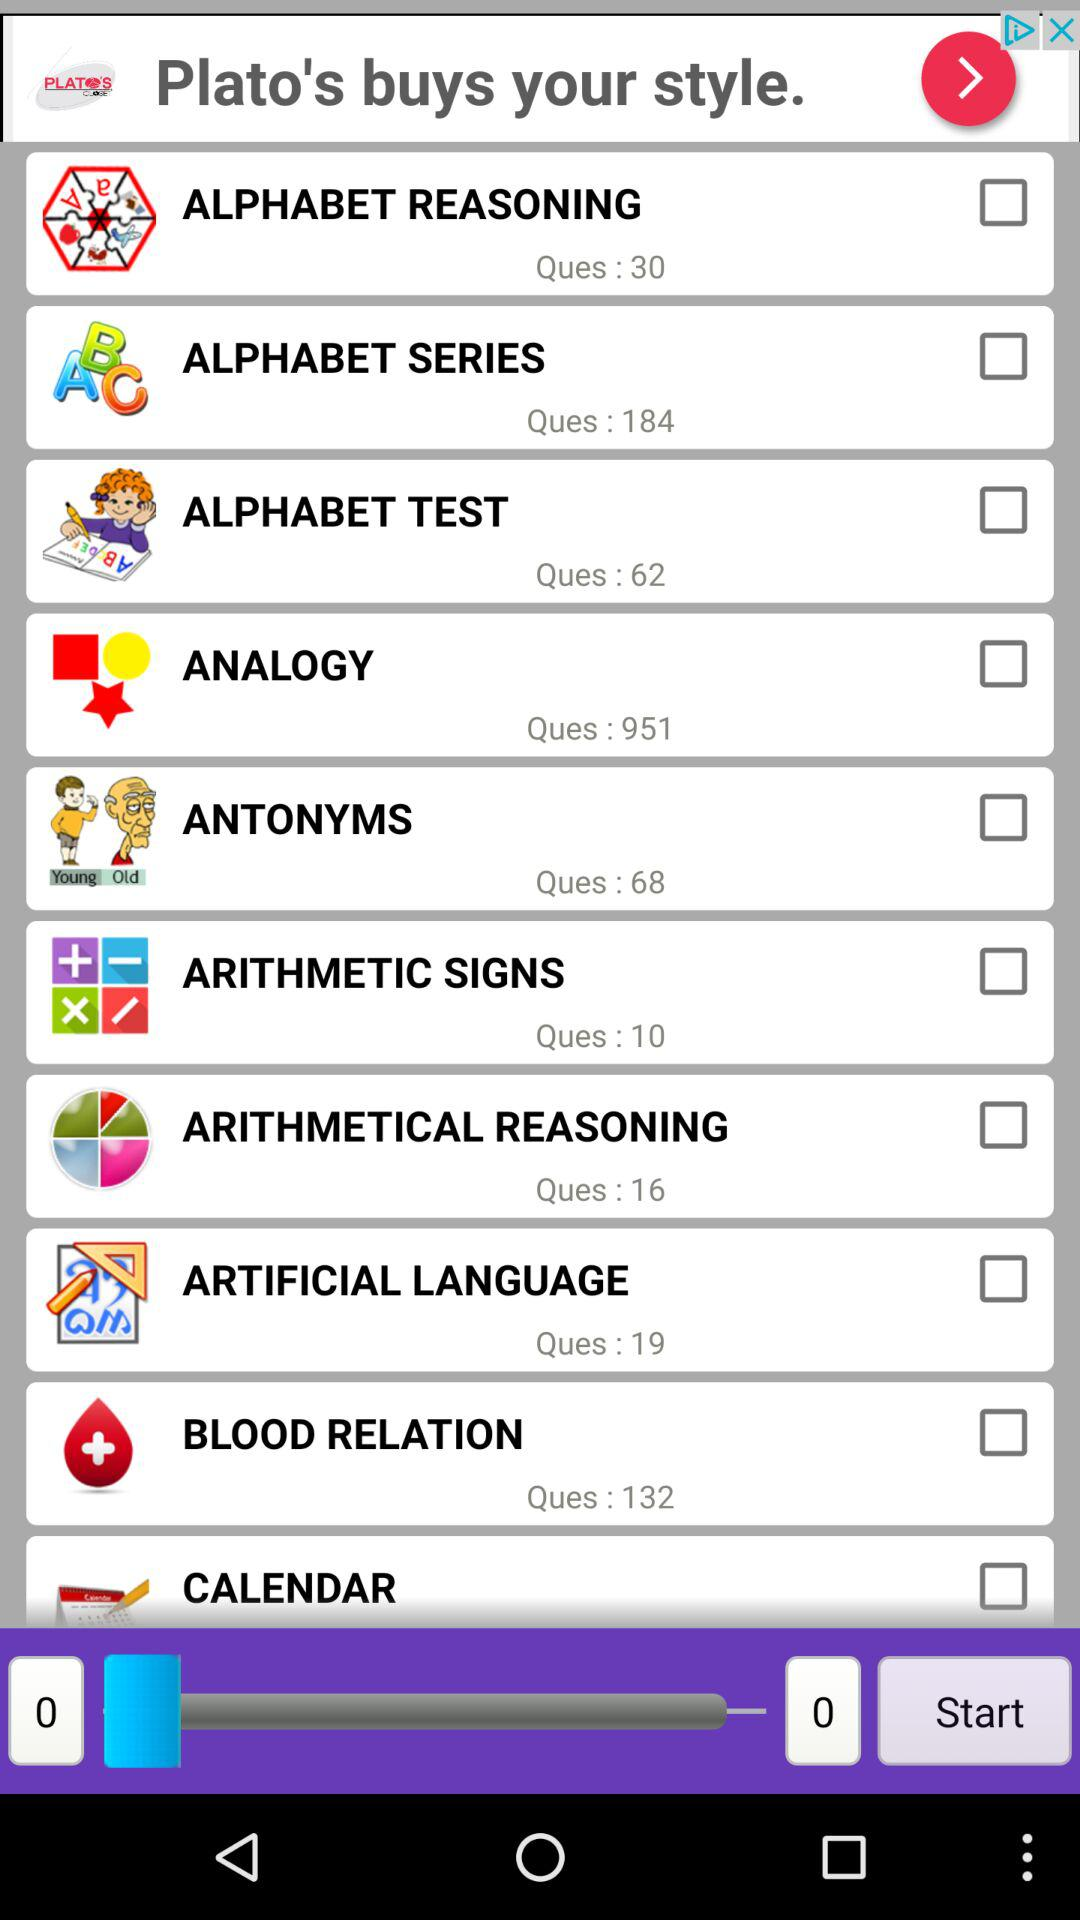What is the number of questions in "ANTONYMS"? The number of questions in "ANTONYMS" is 68. 